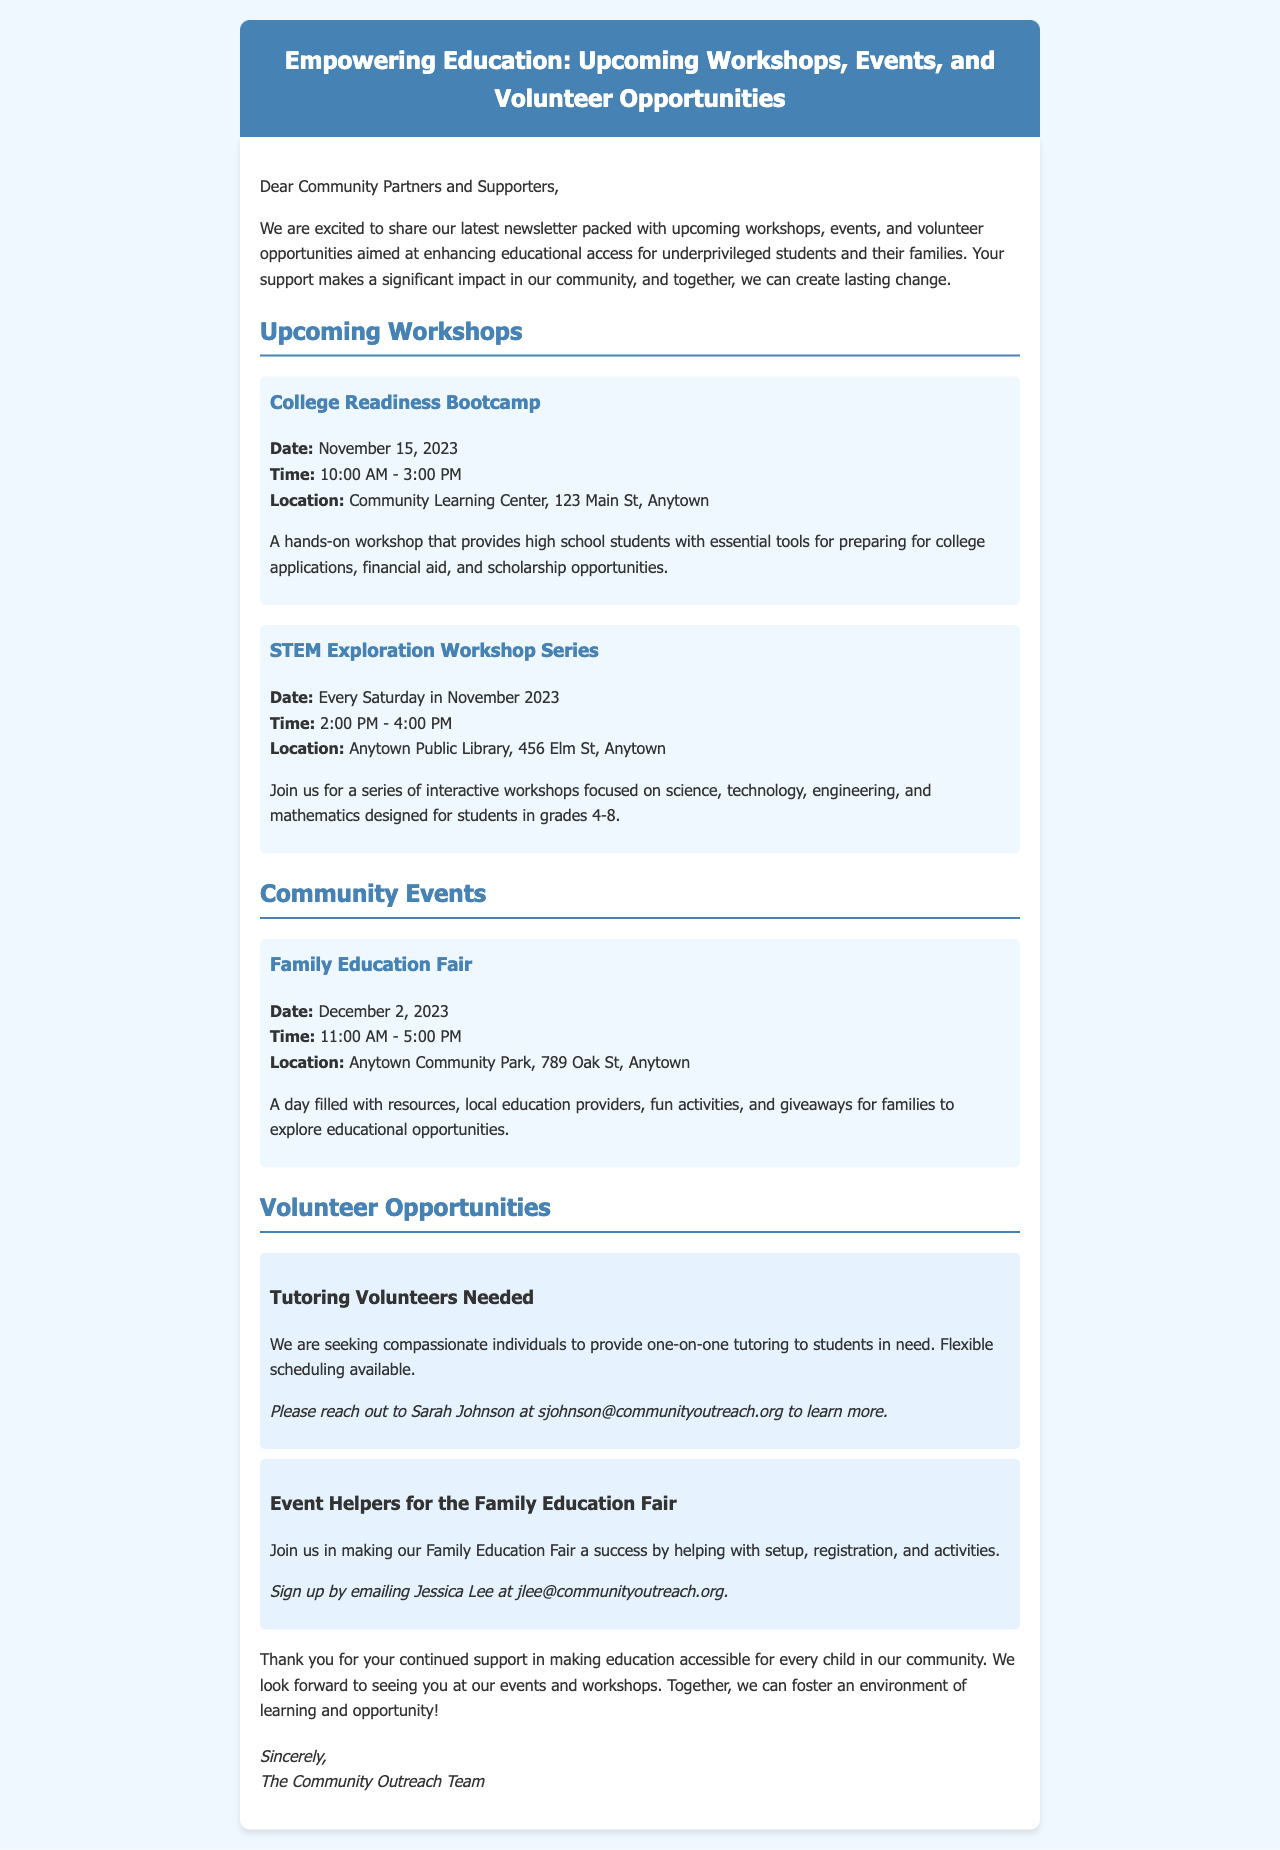What is the title of the newsletter? The title can be found in the header of the newsletter, which introduces the content.
Answer: Empowering Education: Upcoming Workshops, Events, and Volunteer Opportunities When is the College Readiness Bootcamp scheduled? The date for this workshop is specifically mentioned in the events section.
Answer: November 15, 2023 What time does the Family Education Fair start? The starting time is listed under the community events section.
Answer: 11:00 AM How long is the STEM Exploration Workshop Series taking place? This information can be deduced from the details provided in the workshops section about the frequency of the workshops.
Answer: Every Saturday in November 2023 Who do I contact for tutoring volunteer opportunities? The contact person's name is provided along with their email for reaching out about volunteering.
Answer: Sarah Johnson What is one of the activities at the Family Education Fair? The letter describes activities available at the event.
Answer: Fun activities How can one sign up to help with the Family Education Fair? The signing-up process is mentioned in the volunteer opportunities section along with a contact.
Answer: Emailing Jessica Lee What is the location of the College Readiness Bootcamp? The specific location is provided in the details of the workshop.
Answer: Community Learning Center, 123 Main St, Anytown What is the goal of the newsletter? The goal is explicitly stated in the introductory paragraph, summarizing the purpose of the document.
Answer: Enhancing educational access for underprivileged students and their families 